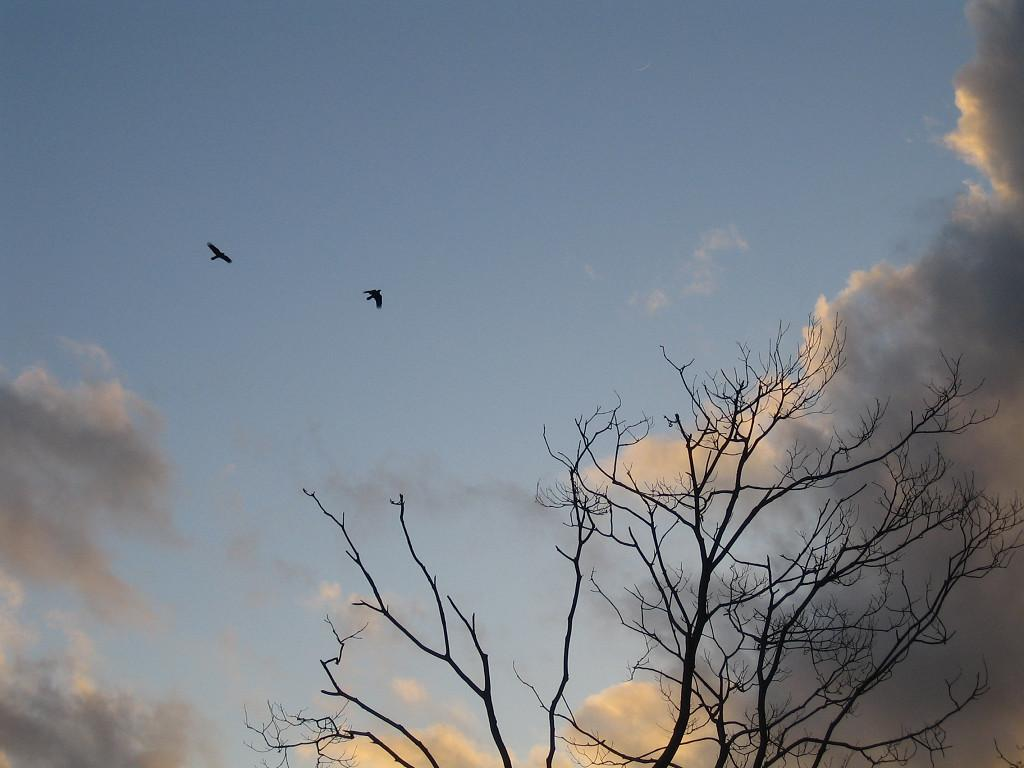What is the main object in the image? There is a tree in the image. What is happening in the sky in the image? There are two birds flying in the image, and clouds are present in the sky. What can be seen in the background of the image? Sky is visible in the background of the image. What type of car is being used for the journey in the image? There is no car or journey present in the image; it features a tree and birds flying in the sky. What game are the birds playing in the image? There is no game being played by the birds in the image; they are simply flying in the sky. 